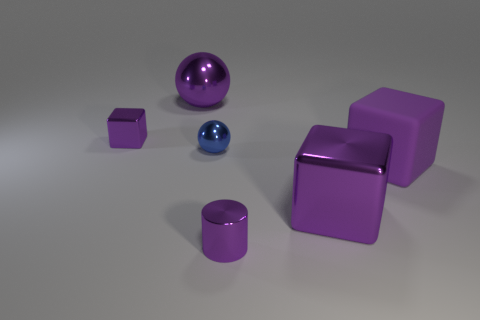What number of matte objects are big brown cylinders or small purple cubes?
Your answer should be compact. 0. The shiny ball behind the cube behind the tiny blue ball is what color?
Give a very brief answer. Purple. Is the tiny purple cylinder made of the same material as the large purple thing that is in front of the big matte object?
Provide a succinct answer. Yes. There is a block that is left of the big cube in front of the big rubber block that is behind the purple shiny cylinder; what is its color?
Provide a short and direct response. Purple. Is there anything else that has the same shape as the blue metal object?
Offer a very short reply. Yes. Is the number of blue cylinders greater than the number of small purple cylinders?
Your response must be concise. No. How many purple blocks are both to the right of the tiny block and on the left side of the rubber thing?
Ensure brevity in your answer.  1. How many shiny cubes are in front of the metal cube that is behind the blue shiny thing?
Make the answer very short. 1. Does the purple shiny block that is to the left of the metallic cylinder have the same size as the metal cube that is right of the blue metallic object?
Your answer should be compact. No. How many small red cylinders are there?
Keep it short and to the point. 0. 